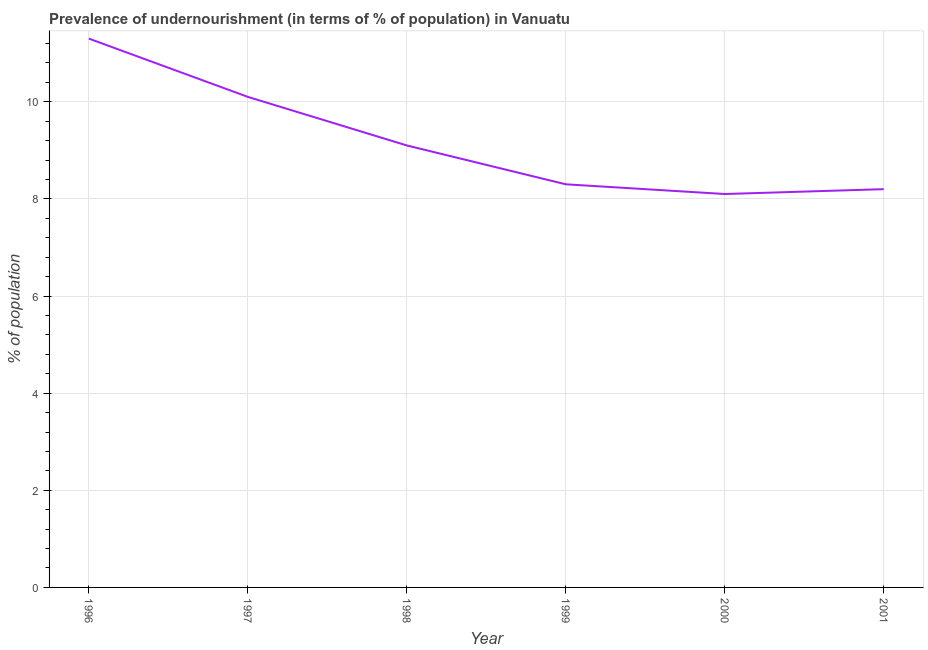What is the percentage of undernourished population in 1997?
Give a very brief answer. 10.1. Across all years, what is the maximum percentage of undernourished population?
Make the answer very short. 11.3. In which year was the percentage of undernourished population minimum?
Offer a terse response. 2000. What is the sum of the percentage of undernourished population?
Your response must be concise. 55.1. What is the difference between the percentage of undernourished population in 1999 and 2000?
Offer a very short reply. 0.2. What is the average percentage of undernourished population per year?
Keep it short and to the point. 9.18. What is the median percentage of undernourished population?
Your answer should be compact. 8.7. What is the ratio of the percentage of undernourished population in 1996 to that in 1997?
Your answer should be very brief. 1.12. Is the difference between the percentage of undernourished population in 1997 and 2001 greater than the difference between any two years?
Your answer should be compact. No. What is the difference between the highest and the second highest percentage of undernourished population?
Offer a terse response. 1.2. What is the difference between the highest and the lowest percentage of undernourished population?
Provide a succinct answer. 3.2. In how many years, is the percentage of undernourished population greater than the average percentage of undernourished population taken over all years?
Provide a short and direct response. 2. How many lines are there?
Your answer should be compact. 1. How many years are there in the graph?
Your answer should be compact. 6. What is the difference between two consecutive major ticks on the Y-axis?
Provide a short and direct response. 2. Does the graph contain any zero values?
Your response must be concise. No. Does the graph contain grids?
Ensure brevity in your answer.  Yes. What is the title of the graph?
Provide a succinct answer. Prevalence of undernourishment (in terms of % of population) in Vanuatu. What is the label or title of the X-axis?
Offer a very short reply. Year. What is the label or title of the Y-axis?
Make the answer very short. % of population. What is the % of population of 1999?
Make the answer very short. 8.3. What is the % of population of 2000?
Your answer should be compact. 8.1. What is the difference between the % of population in 1996 and 1997?
Make the answer very short. 1.2. What is the difference between the % of population in 1996 and 1998?
Provide a succinct answer. 2.2. What is the difference between the % of population in 1996 and 1999?
Ensure brevity in your answer.  3. What is the difference between the % of population in 1996 and 2000?
Provide a short and direct response. 3.2. What is the difference between the % of population in 1996 and 2001?
Ensure brevity in your answer.  3.1. What is the difference between the % of population in 1997 and 2000?
Make the answer very short. 2. What is the difference between the % of population in 1997 and 2001?
Offer a terse response. 1.9. What is the difference between the % of population in 1998 and 2000?
Make the answer very short. 1. What is the difference between the % of population in 1998 and 2001?
Your response must be concise. 0.9. What is the difference between the % of population in 1999 and 2000?
Give a very brief answer. 0.2. What is the difference between the % of population in 1999 and 2001?
Provide a short and direct response. 0.1. What is the difference between the % of population in 2000 and 2001?
Your answer should be compact. -0.1. What is the ratio of the % of population in 1996 to that in 1997?
Keep it short and to the point. 1.12. What is the ratio of the % of population in 1996 to that in 1998?
Your answer should be very brief. 1.24. What is the ratio of the % of population in 1996 to that in 1999?
Offer a very short reply. 1.36. What is the ratio of the % of population in 1996 to that in 2000?
Give a very brief answer. 1.4. What is the ratio of the % of population in 1996 to that in 2001?
Ensure brevity in your answer.  1.38. What is the ratio of the % of population in 1997 to that in 1998?
Your answer should be compact. 1.11. What is the ratio of the % of population in 1997 to that in 1999?
Your answer should be very brief. 1.22. What is the ratio of the % of population in 1997 to that in 2000?
Your answer should be compact. 1.25. What is the ratio of the % of population in 1997 to that in 2001?
Offer a very short reply. 1.23. What is the ratio of the % of population in 1998 to that in 1999?
Ensure brevity in your answer.  1.1. What is the ratio of the % of population in 1998 to that in 2000?
Offer a very short reply. 1.12. What is the ratio of the % of population in 1998 to that in 2001?
Give a very brief answer. 1.11. What is the ratio of the % of population in 1999 to that in 2000?
Make the answer very short. 1.02. What is the ratio of the % of population in 1999 to that in 2001?
Keep it short and to the point. 1.01. 